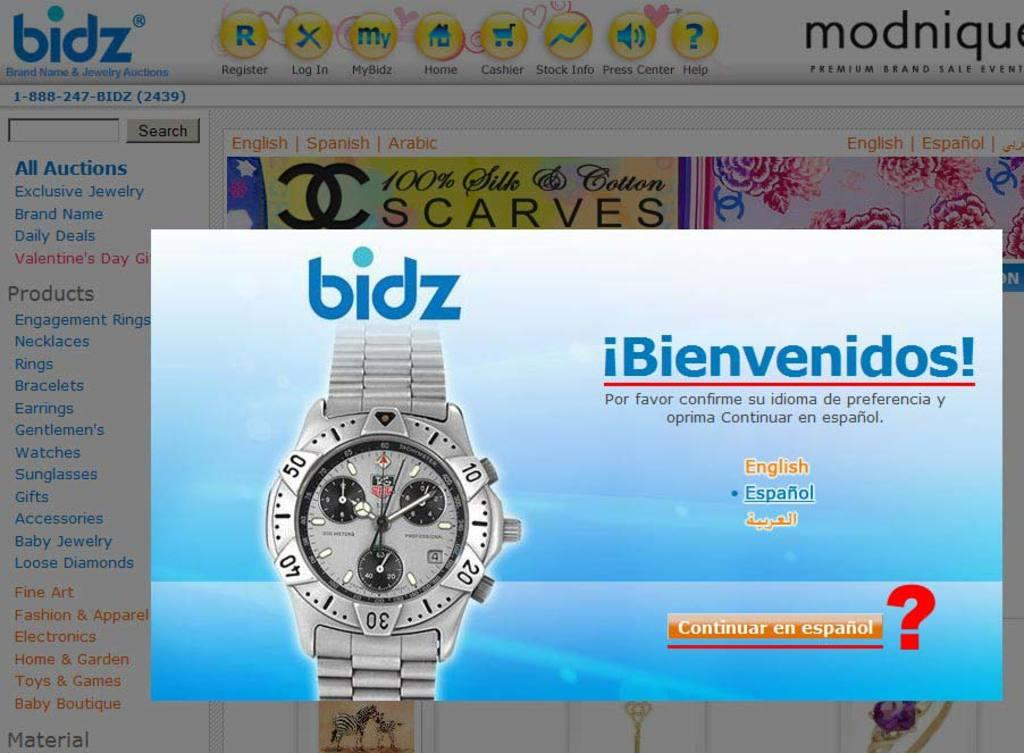<image>
Give a short and clear explanation of the subsequent image. A watch advertisement for the company bidz says bienvenidos. 